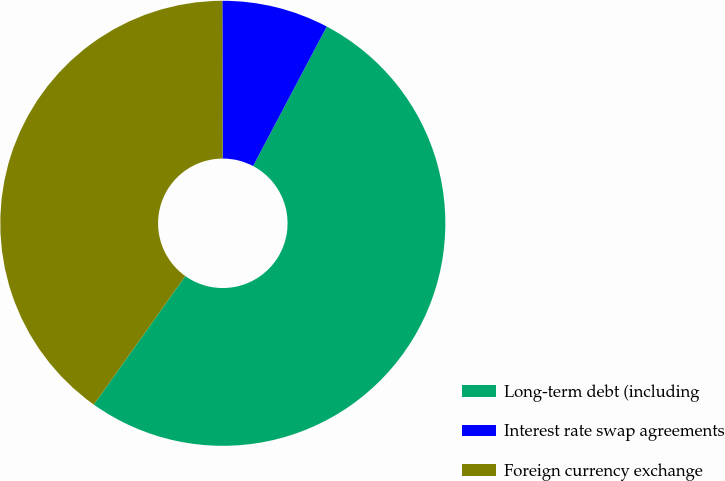<chart> <loc_0><loc_0><loc_500><loc_500><pie_chart><fcel>Long-term debt (including<fcel>Interest rate swap agreements<fcel>Foreign currency exchange<nl><fcel>52.11%<fcel>7.77%<fcel>40.12%<nl></chart> 